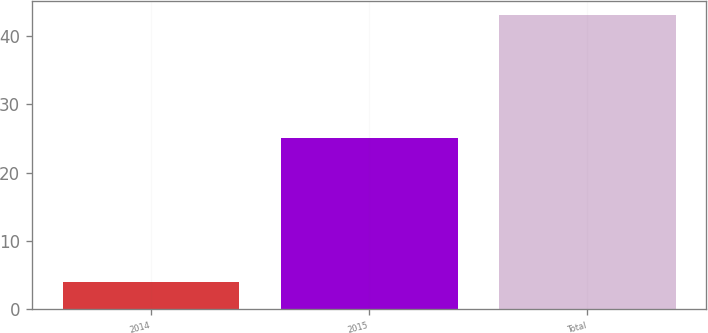Convert chart. <chart><loc_0><loc_0><loc_500><loc_500><bar_chart><fcel>2014<fcel>2015<fcel>Total<nl><fcel>4<fcel>25<fcel>43<nl></chart> 